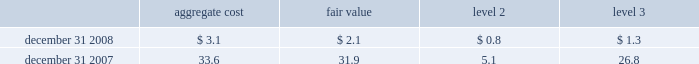- the increase in level 3 short-term borrowings and long-term debt of $ 2.8 billion and $ 7.3 billion , respectively , resulted from transfers in of level 2 positions as prices and other valuation inputs became unobservable , plus the additions of new issuances for fair value accounting was elected .
Items measured at fair value on a nonrecurring basis certain assets and liabilities are measured at fair value on a nonrecurring basis and therefore are not included in the tables above .
These include assets measured at cost that have been written down to fair value during the periods as a result of an impairment .
In addition , assets such as loans held for sale that are measured at the lower of cost or market ( locom ) that were recognized at fair value below cost at the end of the period .
The company recorded goodwill impairment charges of $ 9.6 billion as of december 31 , 2008 , as determined based on level 3 inputs .
The primary cause of goodwill impairment was the overall weak industry outlook and continuing operating losses .
These factors contributed to the overall decline in the stock price and the related market capitalization of citigroup .
See note 19 , 201cgoodwill and intangible assets 201d on page 166 , for additional information on goodwill impairment .
The company performed an impairment analysis of intangible assets related to the old lane multi-strategy hedge fund during the first quarter of 2008 .
As a result , a pre-tax write-down of $ 202 million , representing the remaining unamortized balance of the intangible assets , was recorded during the first quarter of 2008 .
The measurement of fair value was determined using level 3 input factors along with a discounted cash flow approach .
During the fourth quarter of 2008 , the company performed an impairment analysis of japan's nikko asset management fund contracts which represent the rights to manage and collect fees on investor assets and are accounted for as indefinite-lived intangible assets .
As a result , an impairment loss of $ 937 million pre-tax was recorded .
The related fair value was determined using an income approach which relies on key drivers and future expectations of the business that are considered level 3 input factors .
The fair value of loans measured on a locom basis is determined where possible using quoted secondary-market prices .
Such loans are generally classified in level 2 of the fair-value hierarchy given the level of activity in the market and the frequency of available quotes .
If no such quoted price exists , the fair value of a loan is determined using quoted prices for a similar asset or assets , adjusted for the specific attributes of that loan .
The table presents all loans held-for-sale that are carried at locom as of december 31 , 2008 and december 31 , 2007 ( in billions ) : .
Loans held-for-sale that are carried at locom as of december 31 , 2008 significantly declined compared to december 31 , 2007 because most of these loans were either sold or reclassified to held-for-investment category. .
At december 312008 what was the ratio of the recorded goodwill impairment charges to the aggregate value of the loans held for sale? 
Rationale: in 2008 there was $ 3.09 of goodwill impairment recorded for each $ of the aggregate value of the balance of the loans held for sale
Computations: (9.6 / 3.1)
Answer: 3.09677. - the increase in level 3 short-term borrowings and long-term debt of $ 2.8 billion and $ 7.3 billion , respectively , resulted from transfers in of level 2 positions as prices and other valuation inputs became unobservable , plus the additions of new issuances for fair value accounting was elected .
Items measured at fair value on a nonrecurring basis certain assets and liabilities are measured at fair value on a nonrecurring basis and therefore are not included in the tables above .
These include assets measured at cost that have been written down to fair value during the periods as a result of an impairment .
In addition , assets such as loans held for sale that are measured at the lower of cost or market ( locom ) that were recognized at fair value below cost at the end of the period .
The company recorded goodwill impairment charges of $ 9.6 billion as of december 31 , 2008 , as determined based on level 3 inputs .
The primary cause of goodwill impairment was the overall weak industry outlook and continuing operating losses .
These factors contributed to the overall decline in the stock price and the related market capitalization of citigroup .
See note 19 , 201cgoodwill and intangible assets 201d on page 166 , for additional information on goodwill impairment .
The company performed an impairment analysis of intangible assets related to the old lane multi-strategy hedge fund during the first quarter of 2008 .
As a result , a pre-tax write-down of $ 202 million , representing the remaining unamortized balance of the intangible assets , was recorded during the first quarter of 2008 .
The measurement of fair value was determined using level 3 input factors along with a discounted cash flow approach .
During the fourth quarter of 2008 , the company performed an impairment analysis of japan's nikko asset management fund contracts which represent the rights to manage and collect fees on investor assets and are accounted for as indefinite-lived intangible assets .
As a result , an impairment loss of $ 937 million pre-tax was recorded .
The related fair value was determined using an income approach which relies on key drivers and future expectations of the business that are considered level 3 input factors .
The fair value of loans measured on a locom basis is determined where possible using quoted secondary-market prices .
Such loans are generally classified in level 2 of the fair-value hierarchy given the level of activity in the market and the frequency of available quotes .
If no such quoted price exists , the fair value of a loan is determined using quoted prices for a similar asset or assets , adjusted for the specific attributes of that loan .
The table presents all loans held-for-sale that are carried at locom as of december 31 , 2008 and december 31 , 2007 ( in billions ) : .
Loans held-for-sale that are carried at locom as of december 31 , 2008 significantly declined compared to december 31 , 2007 because most of these loans were either sold or reclassified to held-for-investment category. .
What was the change in billions of loans held-for-sale that are carried at locom in the level 3 category from 2007 to 2008? 
Computations: (1.3 - 26.8)
Answer: -25.5. - the increase in level 3 short-term borrowings and long-term debt of $ 2.8 billion and $ 7.3 billion , respectively , resulted from transfers in of level 2 positions as prices and other valuation inputs became unobservable , plus the additions of new issuances for fair value accounting was elected .
Items measured at fair value on a nonrecurring basis certain assets and liabilities are measured at fair value on a nonrecurring basis and therefore are not included in the tables above .
These include assets measured at cost that have been written down to fair value during the periods as a result of an impairment .
In addition , assets such as loans held for sale that are measured at the lower of cost or market ( locom ) that were recognized at fair value below cost at the end of the period .
The company recorded goodwill impairment charges of $ 9.6 billion as of december 31 , 2008 , as determined based on level 3 inputs .
The primary cause of goodwill impairment was the overall weak industry outlook and continuing operating losses .
These factors contributed to the overall decline in the stock price and the related market capitalization of citigroup .
See note 19 , 201cgoodwill and intangible assets 201d on page 166 , for additional information on goodwill impairment .
The company performed an impairment analysis of intangible assets related to the old lane multi-strategy hedge fund during the first quarter of 2008 .
As a result , a pre-tax write-down of $ 202 million , representing the remaining unamortized balance of the intangible assets , was recorded during the first quarter of 2008 .
The measurement of fair value was determined using level 3 input factors along with a discounted cash flow approach .
During the fourth quarter of 2008 , the company performed an impairment analysis of japan's nikko asset management fund contracts which represent the rights to manage and collect fees on investor assets and are accounted for as indefinite-lived intangible assets .
As a result , an impairment loss of $ 937 million pre-tax was recorded .
The related fair value was determined using an income approach which relies on key drivers and future expectations of the business that are considered level 3 input factors .
The fair value of loans measured on a locom basis is determined where possible using quoted secondary-market prices .
Such loans are generally classified in level 2 of the fair-value hierarchy given the level of activity in the market and the frequency of available quotes .
If no such quoted price exists , the fair value of a loan is determined using quoted prices for a similar asset or assets , adjusted for the specific attributes of that loan .
The table presents all loans held-for-sale that are carried at locom as of december 31 , 2008 and december 31 , 2007 ( in billions ) : .
Loans held-for-sale that are carried at locom as of december 31 , 2008 significantly declined compared to december 31 , 2007 because most of these loans were either sold or reclassified to held-for-investment category. .
What was the change in billions of loans held-for-sale that are carried at locom in the level 2 category from 2007 to 2008? 
Computations: (0.8 - 5.1)
Answer: -4.3. 